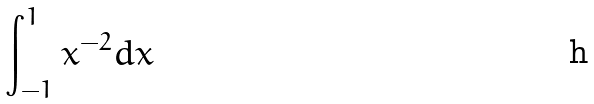<formula> <loc_0><loc_0><loc_500><loc_500>\int _ { - 1 } ^ { 1 } x ^ { - 2 } d x</formula> 